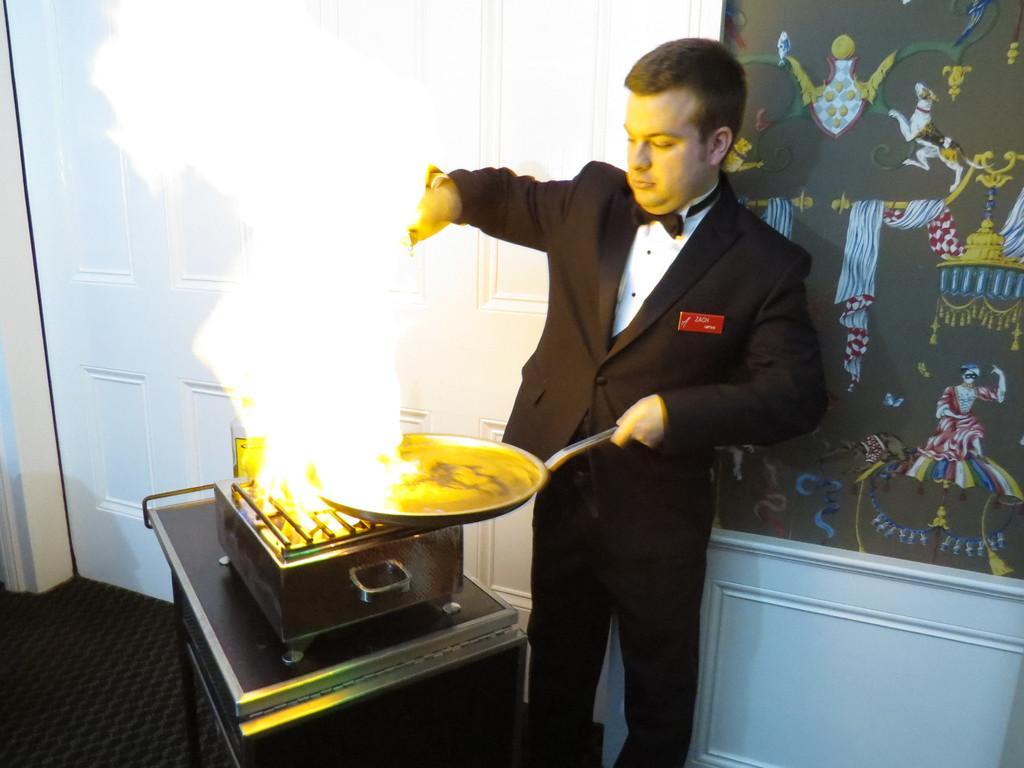Please provide a concise description of this image. In the center of the image we can see a man is standing and cooking and holding a vessel. In-front of him we can see a table. On the table we can see a stove and also we can see fire and smoke. In the background of the image we can see the wall, door, board. At the bottom of the image we can see the floor. 